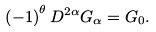Convert formula to latex. <formula><loc_0><loc_0><loc_500><loc_500>\left ( - 1 \right ) ^ { \theta } D ^ { 2 \alpha } G _ { \alpha } = G _ { 0 } .</formula> 